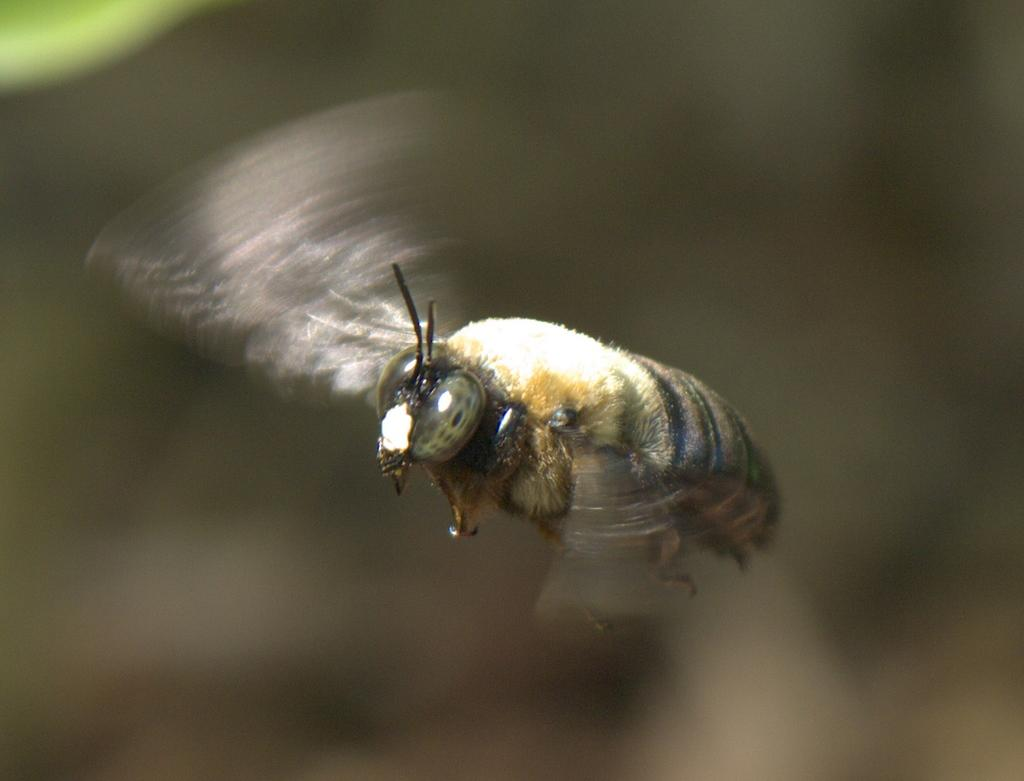What type of creature can be seen in the image? There is an insect in the image. Can you describe the background of the image? The background of the image is blurry. What type of offer is the insect making in the image? There is no indication in the image that the insect is making any offer. 